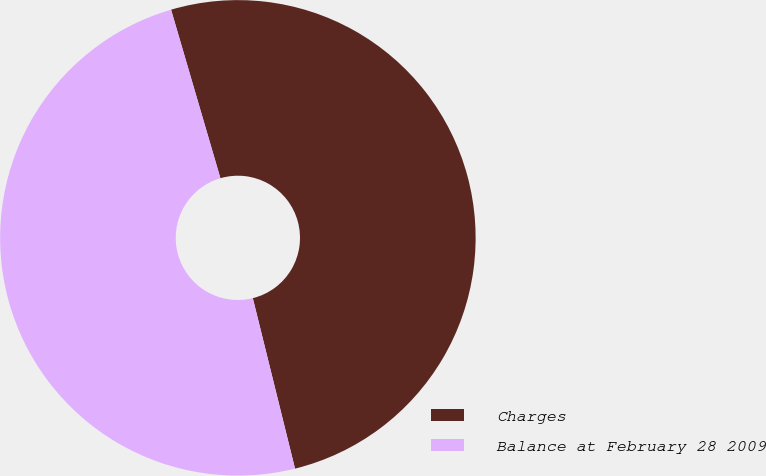Convert chart to OTSL. <chart><loc_0><loc_0><loc_500><loc_500><pie_chart><fcel>Charges<fcel>Balance at February 28 2009<nl><fcel>50.67%<fcel>49.33%<nl></chart> 